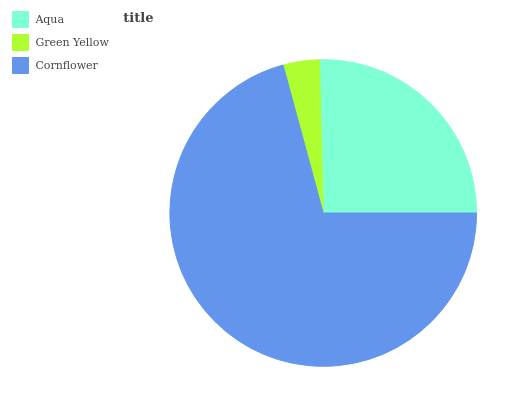Is Green Yellow the minimum?
Answer yes or no. Yes. Is Cornflower the maximum?
Answer yes or no. Yes. Is Cornflower the minimum?
Answer yes or no. No. Is Green Yellow the maximum?
Answer yes or no. No. Is Cornflower greater than Green Yellow?
Answer yes or no. Yes. Is Green Yellow less than Cornflower?
Answer yes or no. Yes. Is Green Yellow greater than Cornflower?
Answer yes or no. No. Is Cornflower less than Green Yellow?
Answer yes or no. No. Is Aqua the high median?
Answer yes or no. Yes. Is Aqua the low median?
Answer yes or no. Yes. Is Cornflower the high median?
Answer yes or no. No. Is Green Yellow the low median?
Answer yes or no. No. 